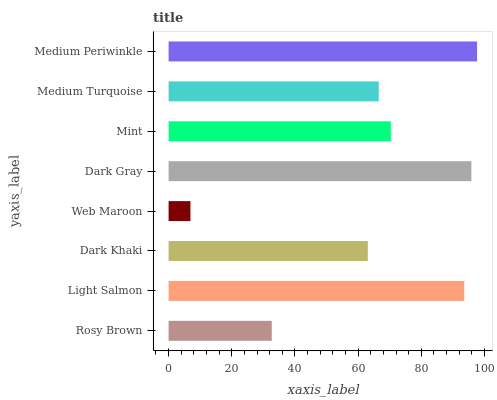Is Web Maroon the minimum?
Answer yes or no. Yes. Is Medium Periwinkle the maximum?
Answer yes or no. Yes. Is Light Salmon the minimum?
Answer yes or no. No. Is Light Salmon the maximum?
Answer yes or no. No. Is Light Salmon greater than Rosy Brown?
Answer yes or no. Yes. Is Rosy Brown less than Light Salmon?
Answer yes or no. Yes. Is Rosy Brown greater than Light Salmon?
Answer yes or no. No. Is Light Salmon less than Rosy Brown?
Answer yes or no. No. Is Mint the high median?
Answer yes or no. Yes. Is Medium Turquoise the low median?
Answer yes or no. Yes. Is Medium Turquoise the high median?
Answer yes or no. No. Is Dark Khaki the low median?
Answer yes or no. No. 